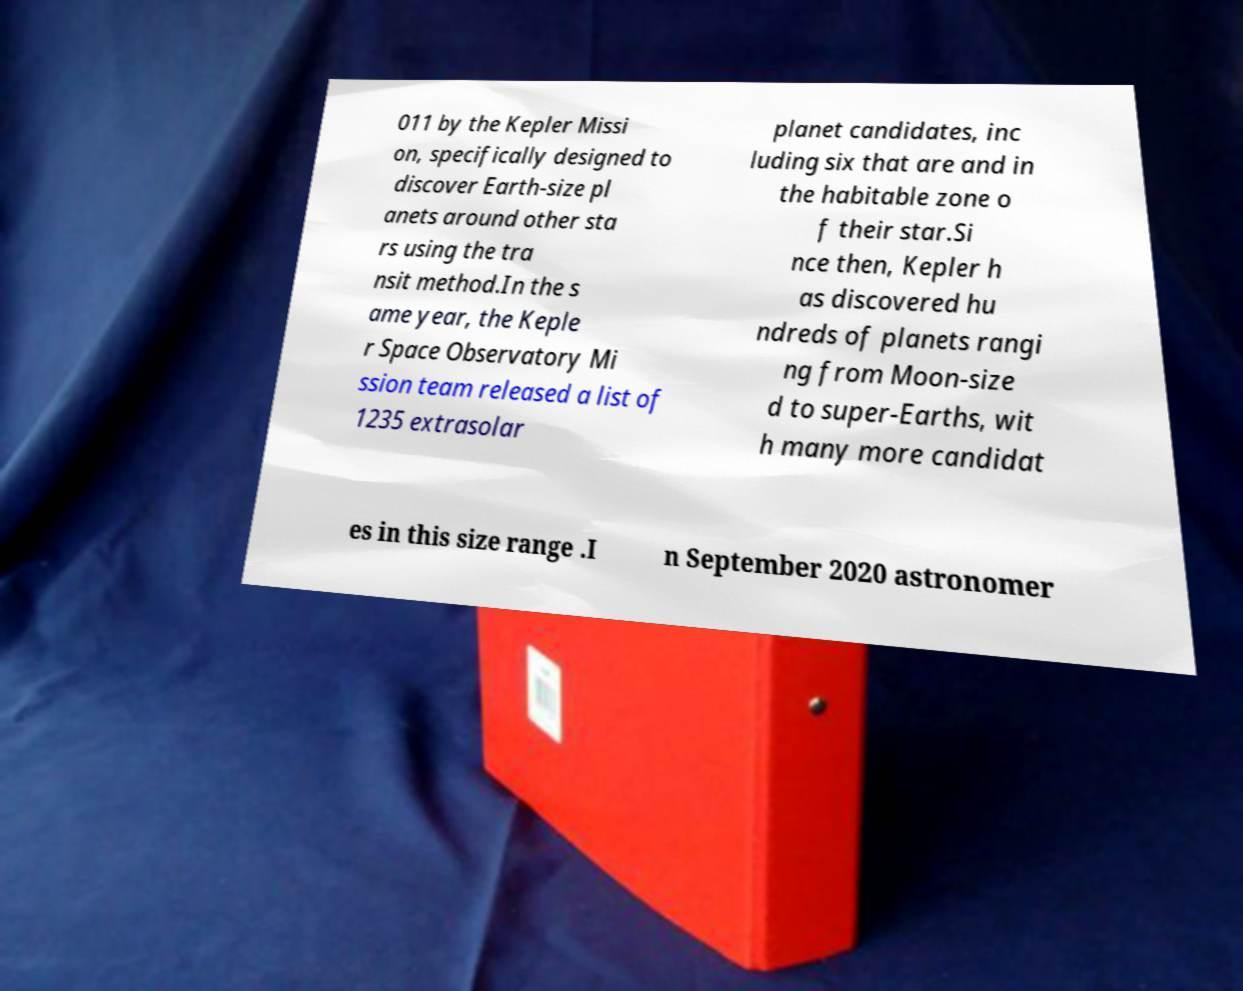Can you read and provide the text displayed in the image?This photo seems to have some interesting text. Can you extract and type it out for me? 011 by the Kepler Missi on, specifically designed to discover Earth-size pl anets around other sta rs using the tra nsit method.In the s ame year, the Keple r Space Observatory Mi ssion team released a list of 1235 extrasolar planet candidates, inc luding six that are and in the habitable zone o f their star.Si nce then, Kepler h as discovered hu ndreds of planets rangi ng from Moon-size d to super-Earths, wit h many more candidat es in this size range .I n September 2020 astronomer 